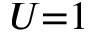<formula> <loc_0><loc_0><loc_500><loc_500>U { = } 1</formula> 